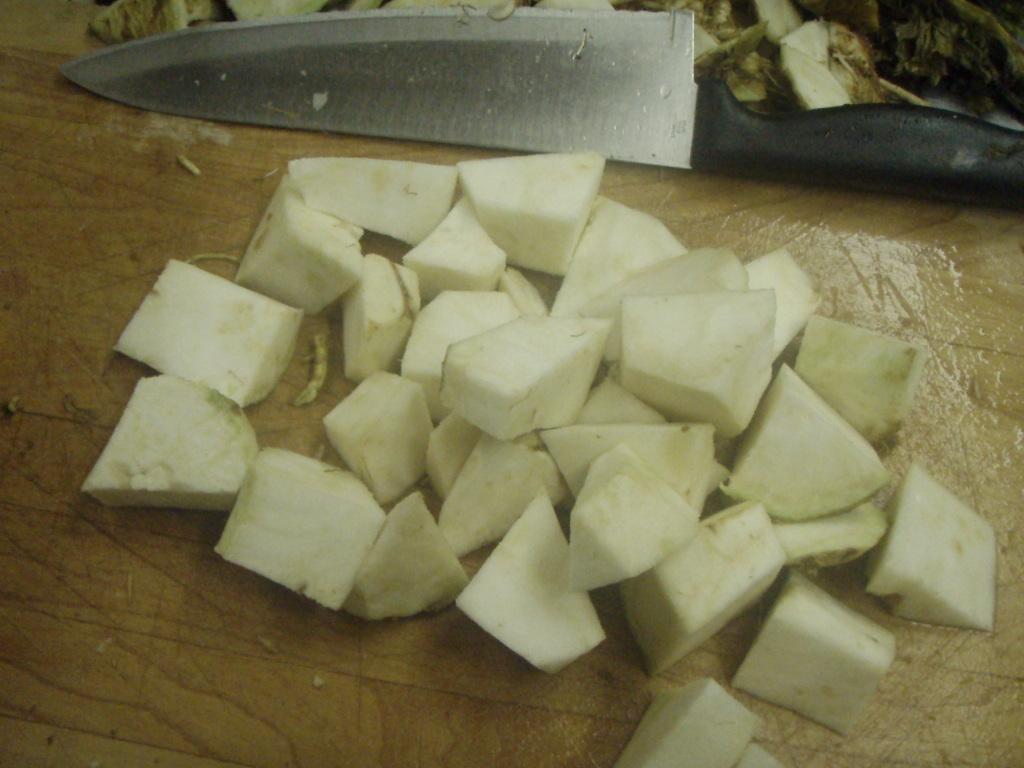How would you summarize this image in a sentence or two? In the center of the image there are chopped vegetables on the table. There is a knife. 